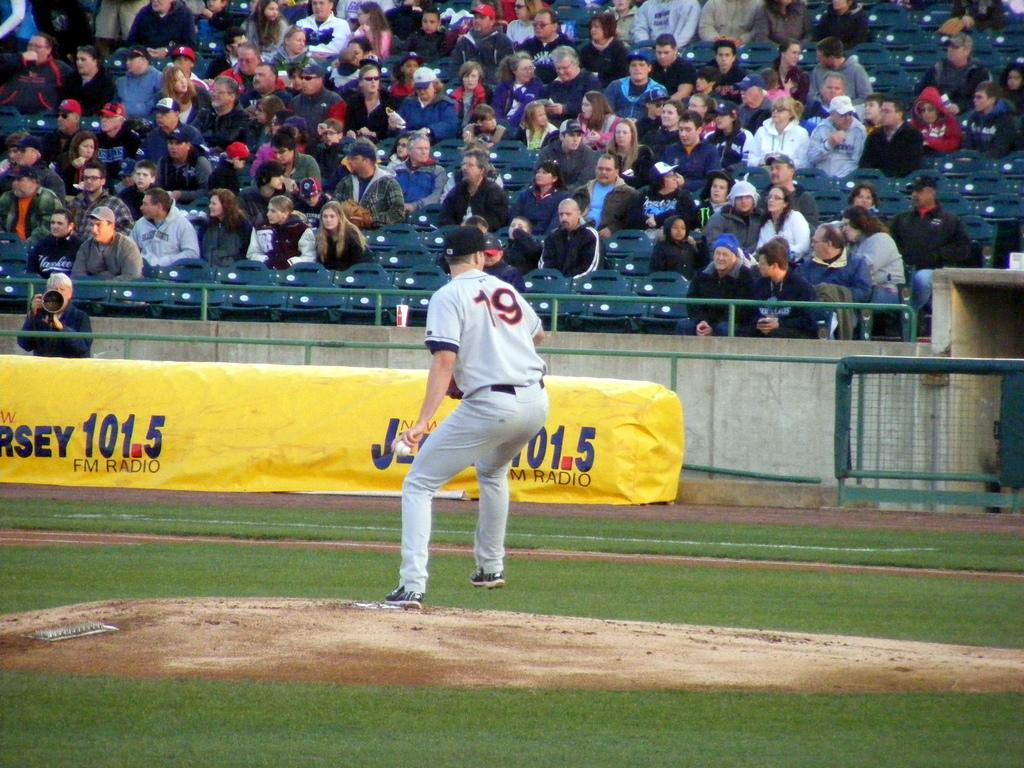<image>
Summarize the visual content of the image. A baseball pitcher wears uniform number 19 while pitching in front of a Jersey 101.5 sign. 